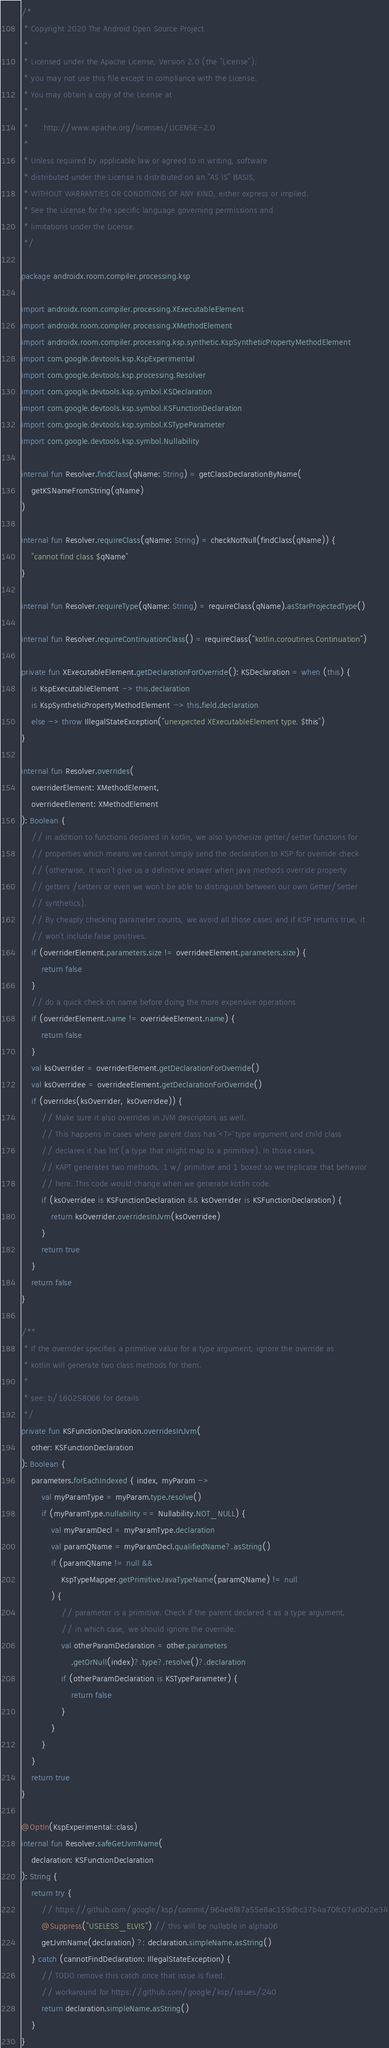Convert code to text. <code><loc_0><loc_0><loc_500><loc_500><_Kotlin_>/*
 * Copyright 2020 The Android Open Source Project
 *
 * Licensed under the Apache License, Version 2.0 (the "License");
 * you may not use this file except in compliance with the License.
 * You may obtain a copy of the License at
 *
 *      http://www.apache.org/licenses/LICENSE-2.0
 *
 * Unless required by applicable law or agreed to in writing, software
 * distributed under the License is distributed on an "AS IS" BASIS,
 * WITHOUT WARRANTIES OR CONDITIONS OF ANY KIND, either express or implied.
 * See the License for the specific language governing permissions and
 * limitations under the License.
 */

package androidx.room.compiler.processing.ksp

import androidx.room.compiler.processing.XExecutableElement
import androidx.room.compiler.processing.XMethodElement
import androidx.room.compiler.processing.ksp.synthetic.KspSyntheticPropertyMethodElement
import com.google.devtools.ksp.KspExperimental
import com.google.devtools.ksp.processing.Resolver
import com.google.devtools.ksp.symbol.KSDeclaration
import com.google.devtools.ksp.symbol.KSFunctionDeclaration
import com.google.devtools.ksp.symbol.KSTypeParameter
import com.google.devtools.ksp.symbol.Nullability

internal fun Resolver.findClass(qName: String) = getClassDeclarationByName(
    getKSNameFromString(qName)
)

internal fun Resolver.requireClass(qName: String) = checkNotNull(findClass(qName)) {
    "cannot find class $qName"
}

internal fun Resolver.requireType(qName: String) = requireClass(qName).asStarProjectedType()

internal fun Resolver.requireContinuationClass() = requireClass("kotlin.coroutines.Continuation")

private fun XExecutableElement.getDeclarationForOverride(): KSDeclaration = when (this) {
    is KspExecutableElement -> this.declaration
    is KspSyntheticPropertyMethodElement -> this.field.declaration
    else -> throw IllegalStateException("unexpected XExecutableElement type. $this")
}

internal fun Resolver.overrides(
    overriderElement: XMethodElement,
    overrideeElement: XMethodElement
): Boolean {
    // in addition to functions declared in kotlin, we also synthesize getter/setter functions for
    // properties which means we cannot simply send the declaration to KSP for override check
    // (otherwise, it won't give us a definitive answer when java methods override property
    // getters /setters or even we won't be able to distinguish between our own Getter/Setter
    // synthetics).
    // By cheaply checking parameter counts, we avoid all those cases and if KSP returns true, it
    // won't include false positives.
    if (overriderElement.parameters.size != overrideeElement.parameters.size) {
        return false
    }
    // do a quick check on name before doing the more expensive operations
    if (overriderElement.name != overrideeElement.name) {
        return false
    }
    val ksOverrider = overriderElement.getDeclarationForOverride()
    val ksOverridee = overrideeElement.getDeclarationForOverride()
    if (overrides(ksOverrider, ksOverridee)) {
        // Make sure it also overrides in JVM descriptors as well.
        // This happens in cases where parent class has `<T>` type argument and child class
        // declares it has `Int` (a type that might map to a primitive). In those cases,
        // KAPT generates two methods, 1 w/ primitive and 1 boxed so we replicate that behavior
        // here. This code would change when we generate kotlin code.
        if (ksOverridee is KSFunctionDeclaration && ksOverrider is KSFunctionDeclaration) {
            return ksOverrider.overridesInJvm(ksOverridee)
        }
        return true
    }
    return false
}

/**
 * If the overrider specifies a primitive value for a type argument, ignore the override as
 * kotlin will generate two class methods for them.
 *
 * see: b/160258066 for details
 */
private fun KSFunctionDeclaration.overridesInJvm(
    other: KSFunctionDeclaration
): Boolean {
    parameters.forEachIndexed { index, myParam ->
        val myParamType = myParam.type.resolve()
        if (myParamType.nullability == Nullability.NOT_NULL) {
            val myParamDecl = myParamType.declaration
            val paramQName = myParamDecl.qualifiedName?.asString()
            if (paramQName != null &&
                KspTypeMapper.getPrimitiveJavaTypeName(paramQName) != null
            ) {
                // parameter is a primitive. Check if the parent declared it as a type argument,
                // in which case, we should ignore the override.
                val otherParamDeclaration = other.parameters
                    .getOrNull(index)?.type?.resolve()?.declaration
                if (otherParamDeclaration is KSTypeParameter) {
                    return false
                }
            }
        }
    }
    return true
}

@OptIn(KspExperimental::class)
internal fun Resolver.safeGetJvmName(
    declaration: KSFunctionDeclaration
): String {
    return try {
        // https://github.com/google/ksp/commit/964e6f87a55e8ac159dbc37b4a70fc07a0b02e34
        @Suppress("USELESS_ELVIS") // this will be nullable in alpha06
        getJvmName(declaration) ?: declaration.simpleName.asString()
    } catch (cannotFindDeclaration: IllegalStateException) {
        // TODO remove this catch once that issue is fixed.
        // workaround for https://github.com/google/ksp/issues/240
        return declaration.simpleName.asString()
    }
}
</code> 